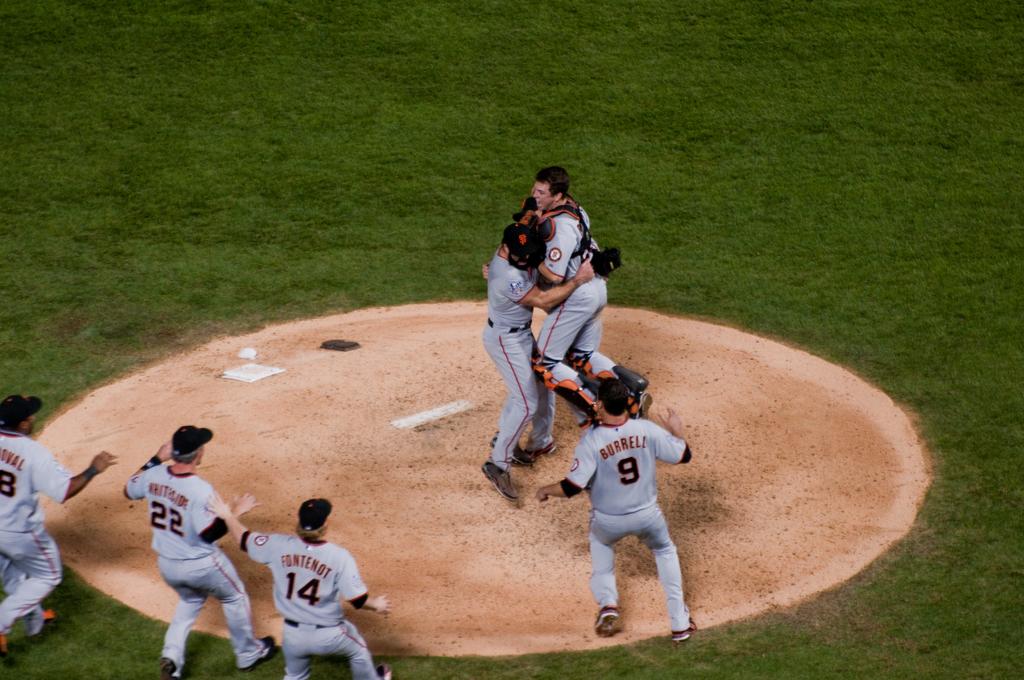What is fontenot's number?
Your answer should be compact. 14. 